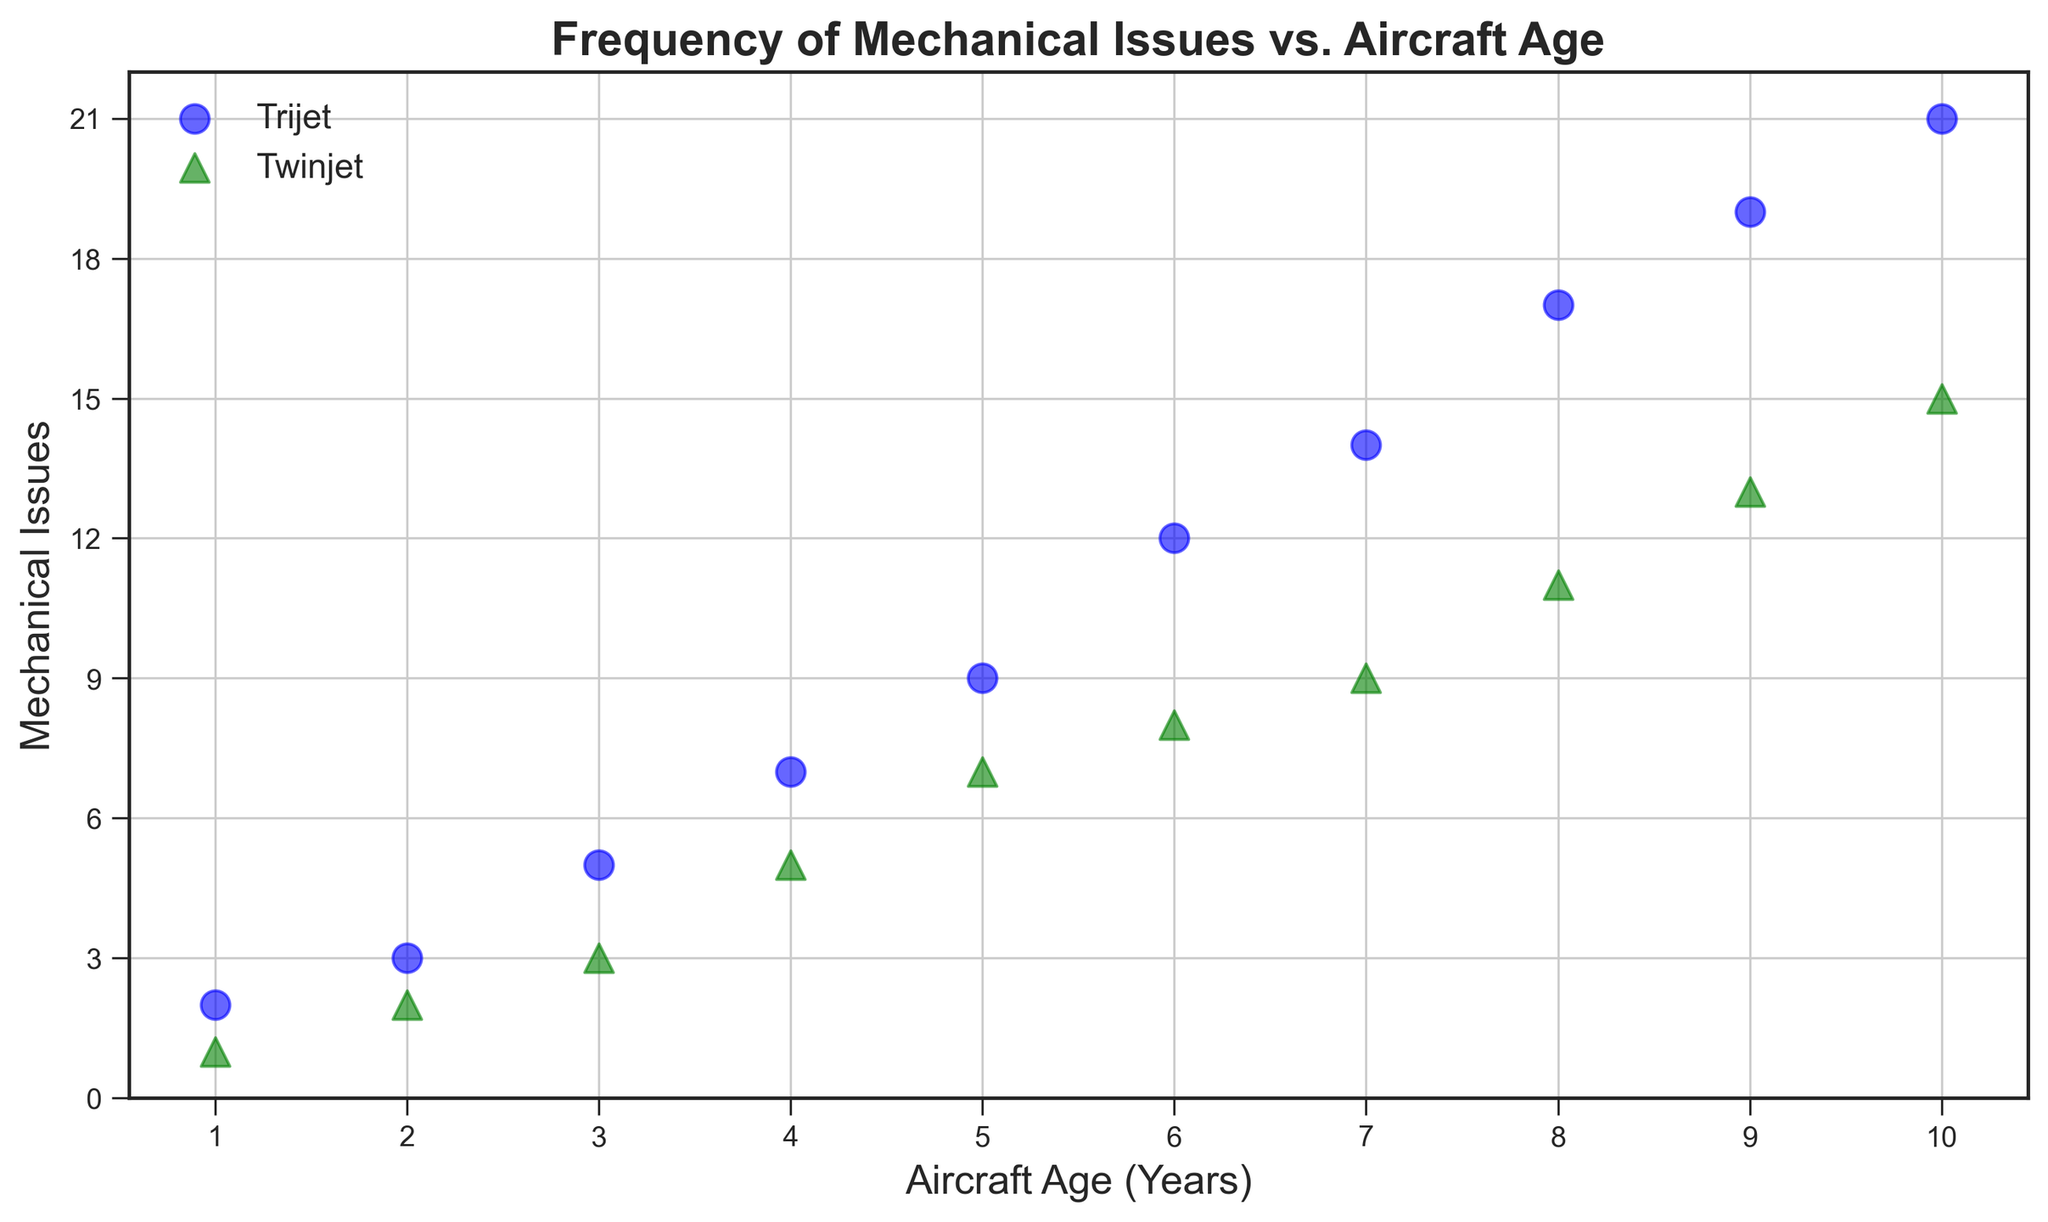What is the maximum number of mechanical issues observed for each aircraft type? For Trijets, the highest point on the scatter plot for mechanical issues is at 21. For Twinjets, the highest point is at 15.
Answer: Trijet: 21, Twinjet: 15 Which aircraft type has a steeper increase in mechanical issues as they age? By observing the slope and distribution of points, Trijets show a quicker and more consistent rise in mechanical issues compared to Twinjets.
Answer: Trijet What is the approximate average number of mechanical issues for Trijets when they are 5 years old? According to the plot, mechanically issues for Trijets at 5 years old are 9.
Answer: 9 Which aircraft type has more mechanical issues at 6 years of age? At 6 years old, Trijets have 12 mechanical issues whereas Twinjets have 8.
Answer: Trijet Which aircraft type shows a roughly linear increase in mechanical issues? Both aircraft types show a generally linear increase, but Trijets show a more consistent linear pattern compared to Twinjets.
Answer: Trijet How does the mechanical issue trend for Twinjets compare between the ages of 8 and 10 years? Between 8 and 10 years, Twinjet mechanical issues increase from 11 to 15, showing a consistent rise.
Answer: Consistent rise What is the difference in mechanical issues between Trijets and Twinjets at 2 years of age? At 2 years old, Trijets have 3 mechanical issues and Twinjets have 2, resulting in a difference of 1.
Answer: 1 At what ages do Trijets and Twinjets have the same number of mechanical issues? Both aircraft types have 3 mechanical issues at 3 years of age.
Answer: 3 years Which aircraft type has fewer mechanical issues at younger ages but catches up at older ages? Twinjets have fewer mechanical issues at younger ages but their trend line catches up and becomes closer to Trijets' trend line as they age.
Answer: Twinjet 